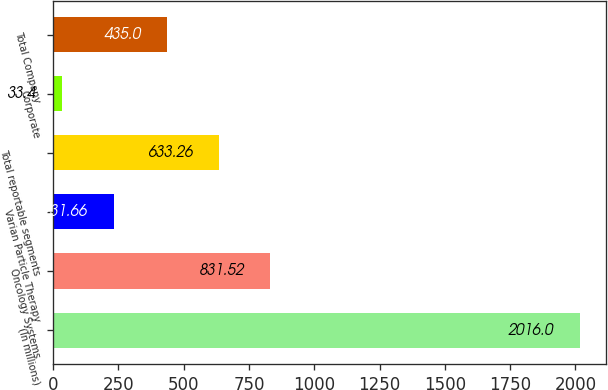<chart> <loc_0><loc_0><loc_500><loc_500><bar_chart><fcel>(In millions)<fcel>Oncology Systems<fcel>Varian Particle Therapy<fcel>Total reportable segments<fcel>Corporate<fcel>Total Company<nl><fcel>2016<fcel>831.52<fcel>231.66<fcel>633.26<fcel>33.4<fcel>435<nl></chart> 